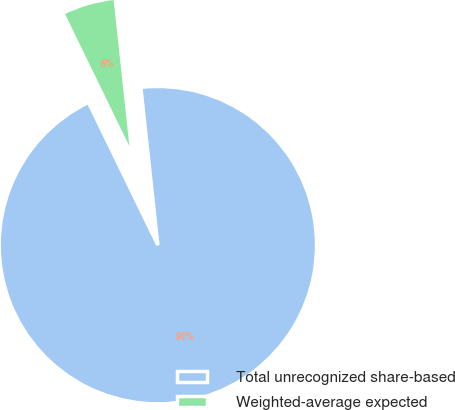<chart> <loc_0><loc_0><loc_500><loc_500><pie_chart><fcel>Total unrecognized share-based<fcel>Weighted-average expected<nl><fcel>94.5%<fcel>5.5%<nl></chart> 